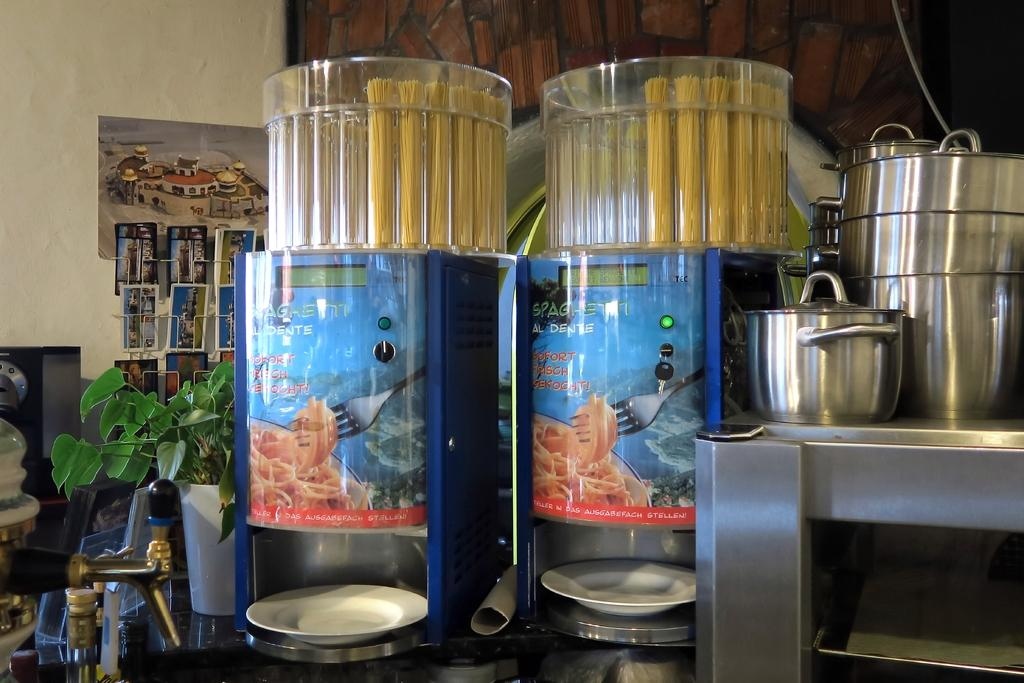Provide a one-sentence caption for the provided image. A kitchen scene with some food containers saying Sohort Reicht. 